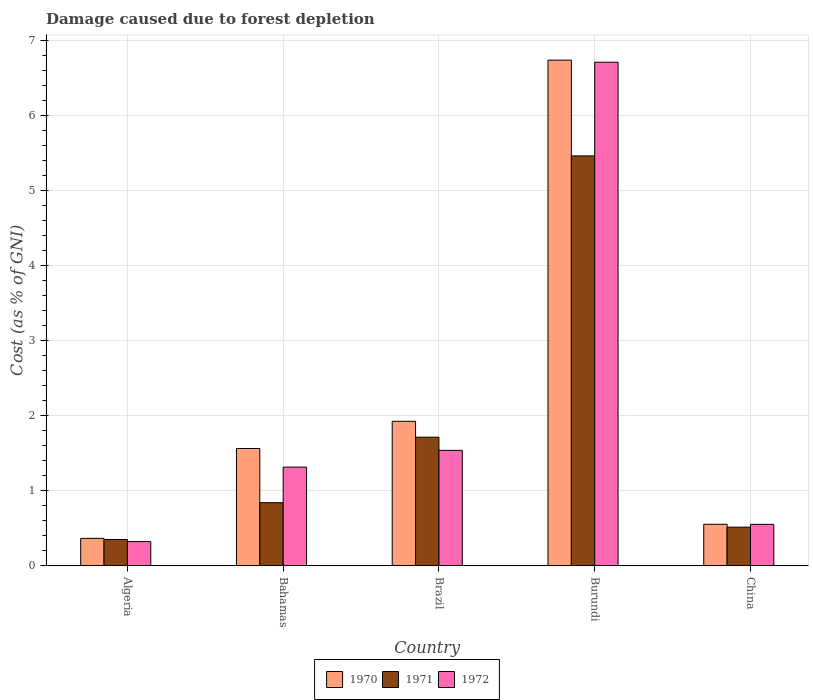How many groups of bars are there?
Offer a terse response. 5. How many bars are there on the 5th tick from the left?
Give a very brief answer. 3. What is the label of the 2nd group of bars from the left?
Provide a succinct answer. Bahamas. In how many cases, is the number of bars for a given country not equal to the number of legend labels?
Ensure brevity in your answer.  0. What is the cost of damage caused due to forest depletion in 1971 in China?
Give a very brief answer. 0.51. Across all countries, what is the maximum cost of damage caused due to forest depletion in 1970?
Make the answer very short. 6.73. Across all countries, what is the minimum cost of damage caused due to forest depletion in 1972?
Your answer should be very brief. 0.32. In which country was the cost of damage caused due to forest depletion in 1972 maximum?
Your response must be concise. Burundi. In which country was the cost of damage caused due to forest depletion in 1971 minimum?
Your answer should be very brief. Algeria. What is the total cost of damage caused due to forest depletion in 1970 in the graph?
Provide a short and direct response. 11.13. What is the difference between the cost of damage caused due to forest depletion in 1972 in Brazil and that in China?
Your response must be concise. 0.99. What is the difference between the cost of damage caused due to forest depletion in 1972 in Burundi and the cost of damage caused due to forest depletion in 1970 in Brazil?
Keep it short and to the point. 4.78. What is the average cost of damage caused due to forest depletion in 1972 per country?
Your answer should be compact. 2.09. What is the difference between the cost of damage caused due to forest depletion of/in 1972 and cost of damage caused due to forest depletion of/in 1971 in Burundi?
Your answer should be compact. 1.25. What is the ratio of the cost of damage caused due to forest depletion in 1972 in Algeria to that in Brazil?
Your answer should be very brief. 0.21. What is the difference between the highest and the second highest cost of damage caused due to forest depletion in 1970?
Ensure brevity in your answer.  0.36. What is the difference between the highest and the lowest cost of damage caused due to forest depletion in 1970?
Provide a short and direct response. 6.37. In how many countries, is the cost of damage caused due to forest depletion in 1970 greater than the average cost of damage caused due to forest depletion in 1970 taken over all countries?
Keep it short and to the point. 1. What does the 1st bar from the left in Bahamas represents?
Offer a terse response. 1970. How many countries are there in the graph?
Give a very brief answer. 5. What is the difference between two consecutive major ticks on the Y-axis?
Offer a terse response. 1. Does the graph contain any zero values?
Provide a short and direct response. No. Where does the legend appear in the graph?
Ensure brevity in your answer.  Bottom center. What is the title of the graph?
Make the answer very short. Damage caused due to forest depletion. Does "1982" appear as one of the legend labels in the graph?
Keep it short and to the point. No. What is the label or title of the X-axis?
Your answer should be compact. Country. What is the label or title of the Y-axis?
Your response must be concise. Cost (as % of GNI). What is the Cost (as % of GNI) of 1970 in Algeria?
Provide a succinct answer. 0.36. What is the Cost (as % of GNI) in 1971 in Algeria?
Provide a succinct answer. 0.35. What is the Cost (as % of GNI) in 1972 in Algeria?
Ensure brevity in your answer.  0.32. What is the Cost (as % of GNI) in 1970 in Bahamas?
Your answer should be very brief. 1.56. What is the Cost (as % of GNI) in 1971 in Bahamas?
Ensure brevity in your answer.  0.84. What is the Cost (as % of GNI) of 1972 in Bahamas?
Your answer should be compact. 1.31. What is the Cost (as % of GNI) of 1970 in Brazil?
Ensure brevity in your answer.  1.92. What is the Cost (as % of GNI) of 1971 in Brazil?
Offer a terse response. 1.71. What is the Cost (as % of GNI) of 1972 in Brazil?
Give a very brief answer. 1.54. What is the Cost (as % of GNI) of 1970 in Burundi?
Your answer should be compact. 6.73. What is the Cost (as % of GNI) of 1971 in Burundi?
Your answer should be very brief. 5.46. What is the Cost (as % of GNI) of 1972 in Burundi?
Your answer should be compact. 6.71. What is the Cost (as % of GNI) of 1970 in China?
Offer a very short reply. 0.55. What is the Cost (as % of GNI) in 1971 in China?
Offer a very short reply. 0.51. What is the Cost (as % of GNI) of 1972 in China?
Provide a succinct answer. 0.55. Across all countries, what is the maximum Cost (as % of GNI) of 1970?
Offer a terse response. 6.73. Across all countries, what is the maximum Cost (as % of GNI) in 1971?
Offer a terse response. 5.46. Across all countries, what is the maximum Cost (as % of GNI) in 1972?
Ensure brevity in your answer.  6.71. Across all countries, what is the minimum Cost (as % of GNI) in 1970?
Make the answer very short. 0.36. Across all countries, what is the minimum Cost (as % of GNI) in 1971?
Keep it short and to the point. 0.35. Across all countries, what is the minimum Cost (as % of GNI) in 1972?
Your answer should be very brief. 0.32. What is the total Cost (as % of GNI) in 1970 in the graph?
Offer a terse response. 11.13. What is the total Cost (as % of GNI) of 1971 in the graph?
Give a very brief answer. 8.87. What is the total Cost (as % of GNI) in 1972 in the graph?
Keep it short and to the point. 10.43. What is the difference between the Cost (as % of GNI) of 1970 in Algeria and that in Bahamas?
Offer a terse response. -1.2. What is the difference between the Cost (as % of GNI) in 1971 in Algeria and that in Bahamas?
Your answer should be compact. -0.49. What is the difference between the Cost (as % of GNI) in 1972 in Algeria and that in Bahamas?
Ensure brevity in your answer.  -0.99. What is the difference between the Cost (as % of GNI) of 1970 in Algeria and that in Brazil?
Offer a very short reply. -1.56. What is the difference between the Cost (as % of GNI) in 1971 in Algeria and that in Brazil?
Make the answer very short. -1.36. What is the difference between the Cost (as % of GNI) of 1972 in Algeria and that in Brazil?
Provide a succinct answer. -1.21. What is the difference between the Cost (as % of GNI) in 1970 in Algeria and that in Burundi?
Keep it short and to the point. -6.37. What is the difference between the Cost (as % of GNI) in 1971 in Algeria and that in Burundi?
Your response must be concise. -5.11. What is the difference between the Cost (as % of GNI) in 1972 in Algeria and that in Burundi?
Your answer should be very brief. -6.38. What is the difference between the Cost (as % of GNI) in 1970 in Algeria and that in China?
Ensure brevity in your answer.  -0.19. What is the difference between the Cost (as % of GNI) of 1971 in Algeria and that in China?
Ensure brevity in your answer.  -0.16. What is the difference between the Cost (as % of GNI) of 1972 in Algeria and that in China?
Offer a very short reply. -0.23. What is the difference between the Cost (as % of GNI) of 1970 in Bahamas and that in Brazil?
Make the answer very short. -0.36. What is the difference between the Cost (as % of GNI) of 1971 in Bahamas and that in Brazil?
Your answer should be compact. -0.87. What is the difference between the Cost (as % of GNI) of 1972 in Bahamas and that in Brazil?
Provide a short and direct response. -0.22. What is the difference between the Cost (as % of GNI) of 1970 in Bahamas and that in Burundi?
Provide a short and direct response. -5.17. What is the difference between the Cost (as % of GNI) of 1971 in Bahamas and that in Burundi?
Ensure brevity in your answer.  -4.62. What is the difference between the Cost (as % of GNI) in 1972 in Bahamas and that in Burundi?
Provide a short and direct response. -5.39. What is the difference between the Cost (as % of GNI) in 1970 in Bahamas and that in China?
Give a very brief answer. 1.01. What is the difference between the Cost (as % of GNI) of 1971 in Bahamas and that in China?
Make the answer very short. 0.33. What is the difference between the Cost (as % of GNI) in 1972 in Bahamas and that in China?
Your answer should be compact. 0.76. What is the difference between the Cost (as % of GNI) of 1970 in Brazil and that in Burundi?
Your answer should be very brief. -4.81. What is the difference between the Cost (as % of GNI) in 1971 in Brazil and that in Burundi?
Provide a short and direct response. -3.75. What is the difference between the Cost (as % of GNI) of 1972 in Brazil and that in Burundi?
Keep it short and to the point. -5.17. What is the difference between the Cost (as % of GNI) of 1970 in Brazil and that in China?
Your answer should be compact. 1.37. What is the difference between the Cost (as % of GNI) of 1971 in Brazil and that in China?
Give a very brief answer. 1.2. What is the difference between the Cost (as % of GNI) in 1972 in Brazil and that in China?
Your response must be concise. 0.99. What is the difference between the Cost (as % of GNI) in 1970 in Burundi and that in China?
Provide a succinct answer. 6.18. What is the difference between the Cost (as % of GNI) in 1971 in Burundi and that in China?
Offer a terse response. 4.94. What is the difference between the Cost (as % of GNI) in 1972 in Burundi and that in China?
Offer a terse response. 6.15. What is the difference between the Cost (as % of GNI) of 1970 in Algeria and the Cost (as % of GNI) of 1971 in Bahamas?
Make the answer very short. -0.47. What is the difference between the Cost (as % of GNI) in 1970 in Algeria and the Cost (as % of GNI) in 1972 in Bahamas?
Your response must be concise. -0.95. What is the difference between the Cost (as % of GNI) of 1971 in Algeria and the Cost (as % of GNI) of 1972 in Bahamas?
Provide a succinct answer. -0.96. What is the difference between the Cost (as % of GNI) of 1970 in Algeria and the Cost (as % of GNI) of 1971 in Brazil?
Offer a very short reply. -1.35. What is the difference between the Cost (as % of GNI) of 1970 in Algeria and the Cost (as % of GNI) of 1972 in Brazil?
Offer a very short reply. -1.17. What is the difference between the Cost (as % of GNI) in 1971 in Algeria and the Cost (as % of GNI) in 1972 in Brazil?
Provide a short and direct response. -1.19. What is the difference between the Cost (as % of GNI) in 1970 in Algeria and the Cost (as % of GNI) in 1971 in Burundi?
Keep it short and to the point. -5.09. What is the difference between the Cost (as % of GNI) in 1970 in Algeria and the Cost (as % of GNI) in 1972 in Burundi?
Provide a succinct answer. -6.34. What is the difference between the Cost (as % of GNI) in 1971 in Algeria and the Cost (as % of GNI) in 1972 in Burundi?
Provide a short and direct response. -6.36. What is the difference between the Cost (as % of GNI) in 1970 in Algeria and the Cost (as % of GNI) in 1971 in China?
Offer a very short reply. -0.15. What is the difference between the Cost (as % of GNI) of 1970 in Algeria and the Cost (as % of GNI) of 1972 in China?
Provide a short and direct response. -0.19. What is the difference between the Cost (as % of GNI) of 1971 in Algeria and the Cost (as % of GNI) of 1972 in China?
Your answer should be very brief. -0.2. What is the difference between the Cost (as % of GNI) in 1970 in Bahamas and the Cost (as % of GNI) in 1971 in Brazil?
Offer a very short reply. -0.15. What is the difference between the Cost (as % of GNI) in 1970 in Bahamas and the Cost (as % of GNI) in 1972 in Brazil?
Provide a succinct answer. 0.02. What is the difference between the Cost (as % of GNI) of 1971 in Bahamas and the Cost (as % of GNI) of 1972 in Brazil?
Provide a succinct answer. -0.7. What is the difference between the Cost (as % of GNI) in 1970 in Bahamas and the Cost (as % of GNI) in 1971 in Burundi?
Your answer should be very brief. -3.9. What is the difference between the Cost (as % of GNI) in 1970 in Bahamas and the Cost (as % of GNI) in 1972 in Burundi?
Your answer should be compact. -5.14. What is the difference between the Cost (as % of GNI) of 1971 in Bahamas and the Cost (as % of GNI) of 1972 in Burundi?
Offer a very short reply. -5.87. What is the difference between the Cost (as % of GNI) in 1970 in Bahamas and the Cost (as % of GNI) in 1971 in China?
Offer a very short reply. 1.05. What is the difference between the Cost (as % of GNI) in 1970 in Bahamas and the Cost (as % of GNI) in 1972 in China?
Your answer should be compact. 1.01. What is the difference between the Cost (as % of GNI) in 1971 in Bahamas and the Cost (as % of GNI) in 1972 in China?
Provide a short and direct response. 0.29. What is the difference between the Cost (as % of GNI) of 1970 in Brazil and the Cost (as % of GNI) of 1971 in Burundi?
Your answer should be compact. -3.53. What is the difference between the Cost (as % of GNI) in 1970 in Brazil and the Cost (as % of GNI) in 1972 in Burundi?
Offer a very short reply. -4.78. What is the difference between the Cost (as % of GNI) of 1971 in Brazil and the Cost (as % of GNI) of 1972 in Burundi?
Make the answer very short. -4.99. What is the difference between the Cost (as % of GNI) of 1970 in Brazil and the Cost (as % of GNI) of 1971 in China?
Provide a succinct answer. 1.41. What is the difference between the Cost (as % of GNI) of 1970 in Brazil and the Cost (as % of GNI) of 1972 in China?
Make the answer very short. 1.37. What is the difference between the Cost (as % of GNI) of 1971 in Brazil and the Cost (as % of GNI) of 1972 in China?
Your answer should be very brief. 1.16. What is the difference between the Cost (as % of GNI) of 1970 in Burundi and the Cost (as % of GNI) of 1971 in China?
Keep it short and to the point. 6.22. What is the difference between the Cost (as % of GNI) in 1970 in Burundi and the Cost (as % of GNI) in 1972 in China?
Make the answer very short. 6.18. What is the difference between the Cost (as % of GNI) of 1971 in Burundi and the Cost (as % of GNI) of 1972 in China?
Provide a short and direct response. 4.91. What is the average Cost (as % of GNI) in 1970 per country?
Keep it short and to the point. 2.23. What is the average Cost (as % of GNI) of 1971 per country?
Your response must be concise. 1.77. What is the average Cost (as % of GNI) of 1972 per country?
Your answer should be very brief. 2.09. What is the difference between the Cost (as % of GNI) of 1970 and Cost (as % of GNI) of 1971 in Algeria?
Your response must be concise. 0.01. What is the difference between the Cost (as % of GNI) in 1970 and Cost (as % of GNI) in 1972 in Algeria?
Your response must be concise. 0.04. What is the difference between the Cost (as % of GNI) in 1971 and Cost (as % of GNI) in 1972 in Algeria?
Make the answer very short. 0.03. What is the difference between the Cost (as % of GNI) of 1970 and Cost (as % of GNI) of 1971 in Bahamas?
Ensure brevity in your answer.  0.72. What is the difference between the Cost (as % of GNI) in 1970 and Cost (as % of GNI) in 1972 in Bahamas?
Your response must be concise. 0.25. What is the difference between the Cost (as % of GNI) in 1971 and Cost (as % of GNI) in 1972 in Bahamas?
Give a very brief answer. -0.47. What is the difference between the Cost (as % of GNI) in 1970 and Cost (as % of GNI) in 1971 in Brazil?
Your answer should be very brief. 0.21. What is the difference between the Cost (as % of GNI) in 1970 and Cost (as % of GNI) in 1972 in Brazil?
Your answer should be very brief. 0.39. What is the difference between the Cost (as % of GNI) in 1971 and Cost (as % of GNI) in 1972 in Brazil?
Keep it short and to the point. 0.18. What is the difference between the Cost (as % of GNI) of 1970 and Cost (as % of GNI) of 1971 in Burundi?
Offer a terse response. 1.28. What is the difference between the Cost (as % of GNI) of 1970 and Cost (as % of GNI) of 1972 in Burundi?
Your answer should be compact. 0.03. What is the difference between the Cost (as % of GNI) in 1971 and Cost (as % of GNI) in 1972 in Burundi?
Offer a terse response. -1.25. What is the difference between the Cost (as % of GNI) of 1970 and Cost (as % of GNI) of 1971 in China?
Ensure brevity in your answer.  0.04. What is the difference between the Cost (as % of GNI) in 1971 and Cost (as % of GNI) in 1972 in China?
Keep it short and to the point. -0.04. What is the ratio of the Cost (as % of GNI) in 1970 in Algeria to that in Bahamas?
Ensure brevity in your answer.  0.23. What is the ratio of the Cost (as % of GNI) of 1971 in Algeria to that in Bahamas?
Your answer should be very brief. 0.42. What is the ratio of the Cost (as % of GNI) of 1972 in Algeria to that in Bahamas?
Provide a short and direct response. 0.24. What is the ratio of the Cost (as % of GNI) of 1970 in Algeria to that in Brazil?
Offer a very short reply. 0.19. What is the ratio of the Cost (as % of GNI) in 1971 in Algeria to that in Brazil?
Give a very brief answer. 0.2. What is the ratio of the Cost (as % of GNI) of 1972 in Algeria to that in Brazil?
Provide a short and direct response. 0.21. What is the ratio of the Cost (as % of GNI) in 1970 in Algeria to that in Burundi?
Your answer should be very brief. 0.05. What is the ratio of the Cost (as % of GNI) in 1971 in Algeria to that in Burundi?
Your answer should be very brief. 0.06. What is the ratio of the Cost (as % of GNI) in 1972 in Algeria to that in Burundi?
Offer a terse response. 0.05. What is the ratio of the Cost (as % of GNI) of 1970 in Algeria to that in China?
Your answer should be very brief. 0.66. What is the ratio of the Cost (as % of GNI) of 1971 in Algeria to that in China?
Your answer should be compact. 0.68. What is the ratio of the Cost (as % of GNI) of 1972 in Algeria to that in China?
Keep it short and to the point. 0.58. What is the ratio of the Cost (as % of GNI) of 1970 in Bahamas to that in Brazil?
Make the answer very short. 0.81. What is the ratio of the Cost (as % of GNI) in 1971 in Bahamas to that in Brazil?
Make the answer very short. 0.49. What is the ratio of the Cost (as % of GNI) in 1972 in Bahamas to that in Brazil?
Offer a terse response. 0.85. What is the ratio of the Cost (as % of GNI) in 1970 in Bahamas to that in Burundi?
Make the answer very short. 0.23. What is the ratio of the Cost (as % of GNI) in 1971 in Bahamas to that in Burundi?
Offer a very short reply. 0.15. What is the ratio of the Cost (as % of GNI) of 1972 in Bahamas to that in Burundi?
Provide a short and direct response. 0.2. What is the ratio of the Cost (as % of GNI) in 1970 in Bahamas to that in China?
Offer a terse response. 2.83. What is the ratio of the Cost (as % of GNI) of 1971 in Bahamas to that in China?
Provide a short and direct response. 1.64. What is the ratio of the Cost (as % of GNI) of 1972 in Bahamas to that in China?
Your answer should be very brief. 2.38. What is the ratio of the Cost (as % of GNI) of 1970 in Brazil to that in Burundi?
Provide a short and direct response. 0.29. What is the ratio of the Cost (as % of GNI) in 1971 in Brazil to that in Burundi?
Keep it short and to the point. 0.31. What is the ratio of the Cost (as % of GNI) of 1972 in Brazil to that in Burundi?
Your answer should be very brief. 0.23. What is the ratio of the Cost (as % of GNI) of 1970 in Brazil to that in China?
Your response must be concise. 3.49. What is the ratio of the Cost (as % of GNI) in 1971 in Brazil to that in China?
Provide a short and direct response. 3.34. What is the ratio of the Cost (as % of GNI) of 1972 in Brazil to that in China?
Offer a terse response. 2.79. What is the ratio of the Cost (as % of GNI) of 1970 in Burundi to that in China?
Keep it short and to the point. 12.2. What is the ratio of the Cost (as % of GNI) in 1971 in Burundi to that in China?
Offer a very short reply. 10.64. What is the ratio of the Cost (as % of GNI) in 1972 in Burundi to that in China?
Your response must be concise. 12.17. What is the difference between the highest and the second highest Cost (as % of GNI) in 1970?
Your answer should be compact. 4.81. What is the difference between the highest and the second highest Cost (as % of GNI) of 1971?
Make the answer very short. 3.75. What is the difference between the highest and the second highest Cost (as % of GNI) in 1972?
Give a very brief answer. 5.17. What is the difference between the highest and the lowest Cost (as % of GNI) of 1970?
Your answer should be compact. 6.37. What is the difference between the highest and the lowest Cost (as % of GNI) of 1971?
Your answer should be compact. 5.11. What is the difference between the highest and the lowest Cost (as % of GNI) in 1972?
Provide a succinct answer. 6.38. 